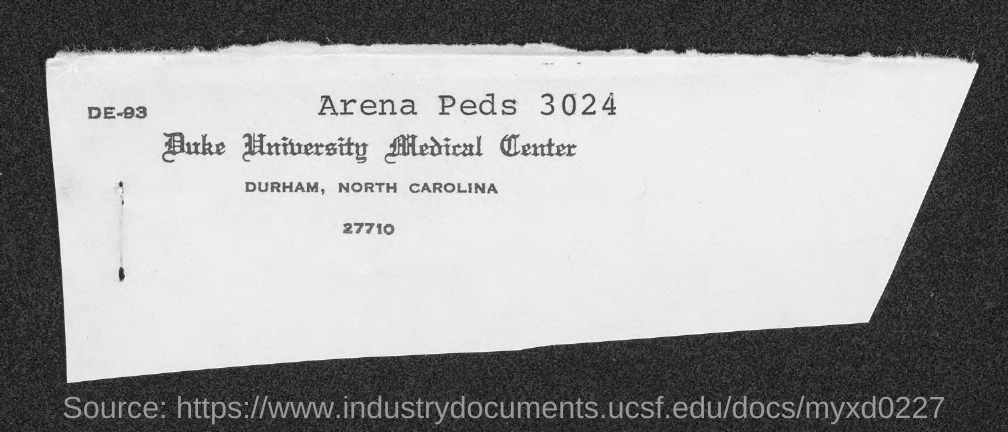Highlight a few significant elements in this photo. The city name where Duke University Medical Center is located is Durham. 